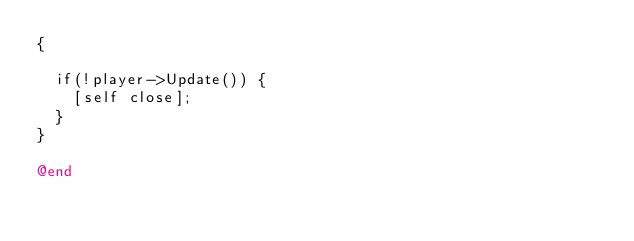Convert code to text. <code><loc_0><loc_0><loc_500><loc_500><_ObjectiveC_>{

	if(!player->Update()) {
		[self close];
	}
}

@end
</code> 